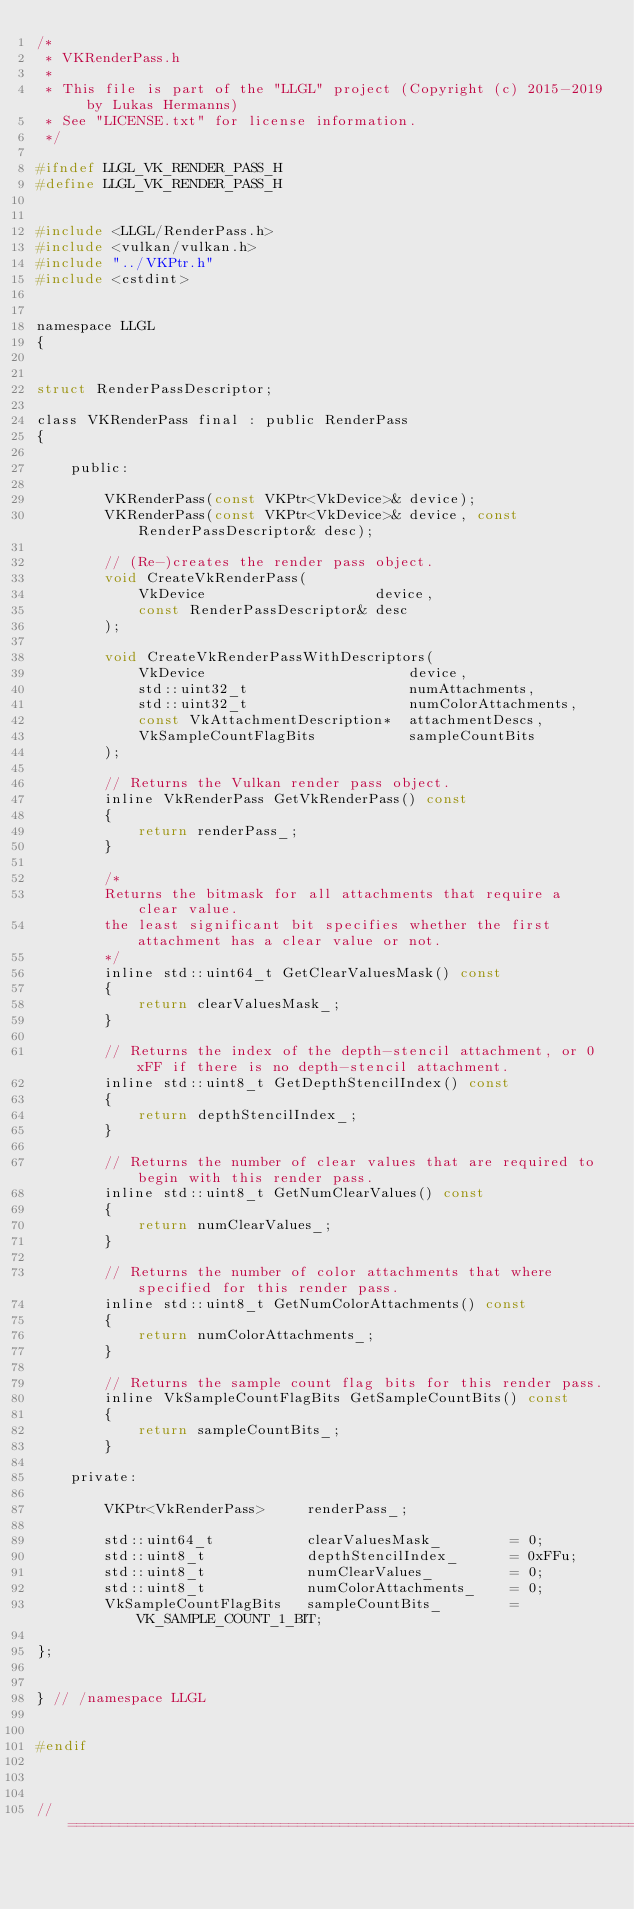Convert code to text. <code><loc_0><loc_0><loc_500><loc_500><_C_>/*
 * VKRenderPass.h
 * 
 * This file is part of the "LLGL" project (Copyright (c) 2015-2019 by Lukas Hermanns)
 * See "LICENSE.txt" for license information.
 */

#ifndef LLGL_VK_RENDER_PASS_H
#define LLGL_VK_RENDER_PASS_H


#include <LLGL/RenderPass.h>
#include <vulkan/vulkan.h>
#include "../VKPtr.h"
#include <cstdint>


namespace LLGL
{


struct RenderPassDescriptor;

class VKRenderPass final : public RenderPass
{

    public:

        VKRenderPass(const VKPtr<VkDevice>& device);
        VKRenderPass(const VKPtr<VkDevice>& device, const RenderPassDescriptor& desc);

        // (Re-)creates the render pass object.
        void CreateVkRenderPass(
            VkDevice                    device,
            const RenderPassDescriptor& desc
        );

        void CreateVkRenderPassWithDescriptors(
            VkDevice                        device,
            std::uint32_t                   numAttachments,
            std::uint32_t                   numColorAttachments,
            const VkAttachmentDescription*  attachmentDescs,
            VkSampleCountFlagBits           sampleCountBits
        );

        // Returns the Vulkan render pass object.
        inline VkRenderPass GetVkRenderPass() const
        {
            return renderPass_;
        }

        /*
        Returns the bitmask for all attachments that require a clear value.
        the least significant bit specifies whether the first attachment has a clear value or not.
        */
        inline std::uint64_t GetClearValuesMask() const
        {
            return clearValuesMask_;
        }

        // Returns the index of the depth-stencil attachment, or 0xFF if there is no depth-stencil attachment.
        inline std::uint8_t GetDepthStencilIndex() const
        {
            return depthStencilIndex_;
        }

        // Returns the number of clear values that are required to begin with this render pass.
        inline std::uint8_t GetNumClearValues() const
        {
            return numClearValues_;
        }

        // Returns the number of color attachments that where specified for this render pass.
        inline std::uint8_t GetNumColorAttachments() const
        {
            return numColorAttachments_;
        }

        // Returns the sample count flag bits for this render pass.
        inline VkSampleCountFlagBits GetSampleCountBits() const
        {
            return sampleCountBits_;
        }

    private:

        VKPtr<VkRenderPass>     renderPass_;

        std::uint64_t           clearValuesMask_        = 0;
        std::uint8_t            depthStencilIndex_      = 0xFFu;
        std::uint8_t            numClearValues_         = 0;
        std::uint8_t            numColorAttachments_    = 0;
        VkSampleCountFlagBits   sampleCountBits_        = VK_SAMPLE_COUNT_1_BIT;

};


} // /namespace LLGL


#endif



// ================================================================================
</code> 